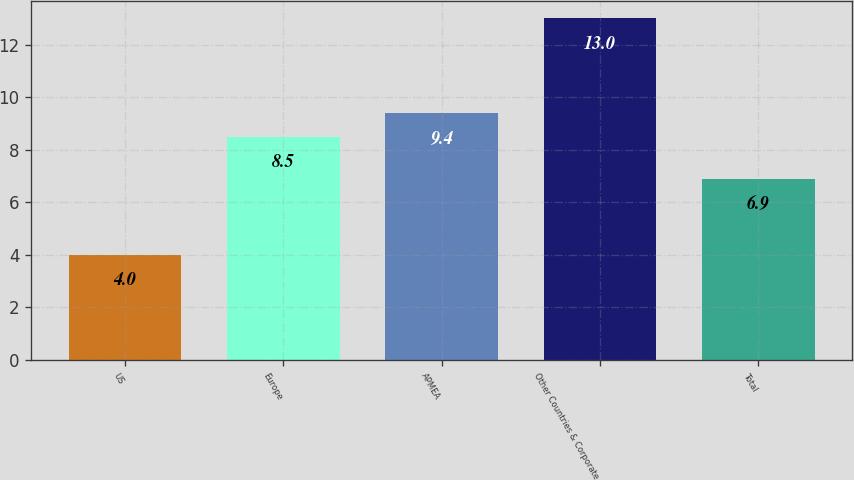Convert chart. <chart><loc_0><loc_0><loc_500><loc_500><bar_chart><fcel>US<fcel>Europe<fcel>APMEA<fcel>Other Countries & Corporate<fcel>Total<nl><fcel>4<fcel>8.5<fcel>9.4<fcel>13<fcel>6.9<nl></chart> 